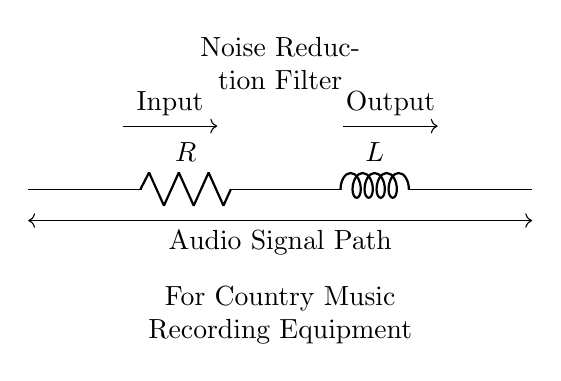What are the components in this circuit? The circuit consists of a resistor and an inductor, labeled as R and L respectively, which are connected in series.
Answer: Resistor and Inductor What is the main function of this circuit? This circuit acts as a noise reduction filter, aimed at improving audio quality for recording equipment.
Answer: Noise Reduction Filter How are the components connected in the circuit? The resistor is connected in series with the inductor, forming a single path for current flow through both components.
Answer: Series What type of filter does this circuit represent? This is a low-pass filter because it allows low-frequency signals to pass while attenuating higher frequencies, useful for noise reduction.
Answer: Low-pass filter What happens to high-frequency noise signals in this circuit? High-frequency signals experience greater attenuation as they are impeded more by the combination of the resistor and inductor in the circuit.
Answer: Attenuated Why are resistors used in combination with inductors in audio circuits? Resistors help to dampen the circuit's response, thereby preventing excessive ringing and ensuring a smoother output signal for audio clarity.
Answer: Damping How does the inductor influence the filter’s performance? The inductor provides reactance that increases with frequency, thereby blocking higher-frequency signals and allowing low-frequency audio signals to pass.
Answer: Blocks high frequencies 